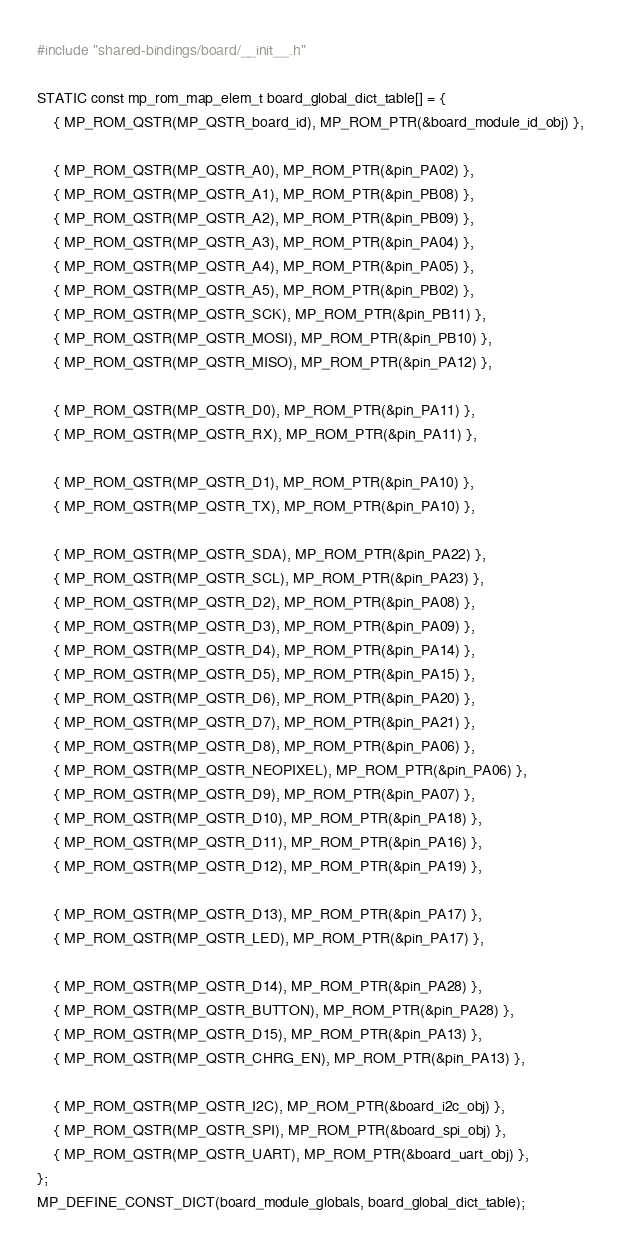Convert code to text. <code><loc_0><loc_0><loc_500><loc_500><_C_>#include "shared-bindings/board/__init__.h"

STATIC const mp_rom_map_elem_t board_global_dict_table[] = {
    { MP_ROM_QSTR(MP_QSTR_board_id), MP_ROM_PTR(&board_module_id_obj) },

    { MP_ROM_QSTR(MP_QSTR_A0), MP_ROM_PTR(&pin_PA02) },
    { MP_ROM_QSTR(MP_QSTR_A1), MP_ROM_PTR(&pin_PB08) },
    { MP_ROM_QSTR(MP_QSTR_A2), MP_ROM_PTR(&pin_PB09) },
    { MP_ROM_QSTR(MP_QSTR_A3), MP_ROM_PTR(&pin_PA04) },
    { MP_ROM_QSTR(MP_QSTR_A4), MP_ROM_PTR(&pin_PA05) },
    { MP_ROM_QSTR(MP_QSTR_A5), MP_ROM_PTR(&pin_PB02) },
    { MP_ROM_QSTR(MP_QSTR_SCK), MP_ROM_PTR(&pin_PB11) },
    { MP_ROM_QSTR(MP_QSTR_MOSI), MP_ROM_PTR(&pin_PB10) },
    { MP_ROM_QSTR(MP_QSTR_MISO), MP_ROM_PTR(&pin_PA12) },

    { MP_ROM_QSTR(MP_QSTR_D0), MP_ROM_PTR(&pin_PA11) },
    { MP_ROM_QSTR(MP_QSTR_RX), MP_ROM_PTR(&pin_PA11) },

    { MP_ROM_QSTR(MP_QSTR_D1), MP_ROM_PTR(&pin_PA10) },
    { MP_ROM_QSTR(MP_QSTR_TX), MP_ROM_PTR(&pin_PA10) },

    { MP_ROM_QSTR(MP_QSTR_SDA), MP_ROM_PTR(&pin_PA22) },
    { MP_ROM_QSTR(MP_QSTR_SCL), MP_ROM_PTR(&pin_PA23) },
    { MP_ROM_QSTR(MP_QSTR_D2), MP_ROM_PTR(&pin_PA08) },
    { MP_ROM_QSTR(MP_QSTR_D3), MP_ROM_PTR(&pin_PA09) },
    { MP_ROM_QSTR(MP_QSTR_D4), MP_ROM_PTR(&pin_PA14) },
    { MP_ROM_QSTR(MP_QSTR_D5), MP_ROM_PTR(&pin_PA15) },
    { MP_ROM_QSTR(MP_QSTR_D6), MP_ROM_PTR(&pin_PA20) },
    { MP_ROM_QSTR(MP_QSTR_D7), MP_ROM_PTR(&pin_PA21) },
    { MP_ROM_QSTR(MP_QSTR_D8), MP_ROM_PTR(&pin_PA06) },
    { MP_ROM_QSTR(MP_QSTR_NEOPIXEL), MP_ROM_PTR(&pin_PA06) },
    { MP_ROM_QSTR(MP_QSTR_D9), MP_ROM_PTR(&pin_PA07) },
    { MP_ROM_QSTR(MP_QSTR_D10), MP_ROM_PTR(&pin_PA18) },
    { MP_ROM_QSTR(MP_QSTR_D11), MP_ROM_PTR(&pin_PA16) },
    { MP_ROM_QSTR(MP_QSTR_D12), MP_ROM_PTR(&pin_PA19) },

    { MP_ROM_QSTR(MP_QSTR_D13), MP_ROM_PTR(&pin_PA17) },
    { MP_ROM_QSTR(MP_QSTR_LED), MP_ROM_PTR(&pin_PA17) },

    { MP_ROM_QSTR(MP_QSTR_D14), MP_ROM_PTR(&pin_PA28) },
    { MP_ROM_QSTR(MP_QSTR_BUTTON), MP_ROM_PTR(&pin_PA28) },
    { MP_ROM_QSTR(MP_QSTR_D15), MP_ROM_PTR(&pin_PA13) },
    { MP_ROM_QSTR(MP_QSTR_CHRG_EN), MP_ROM_PTR(&pin_PA13) },

    { MP_ROM_QSTR(MP_QSTR_I2C), MP_ROM_PTR(&board_i2c_obj) },
    { MP_ROM_QSTR(MP_QSTR_SPI), MP_ROM_PTR(&board_spi_obj) },
    { MP_ROM_QSTR(MP_QSTR_UART), MP_ROM_PTR(&board_uart_obj) },
};
MP_DEFINE_CONST_DICT(board_module_globals, board_global_dict_table);
</code> 